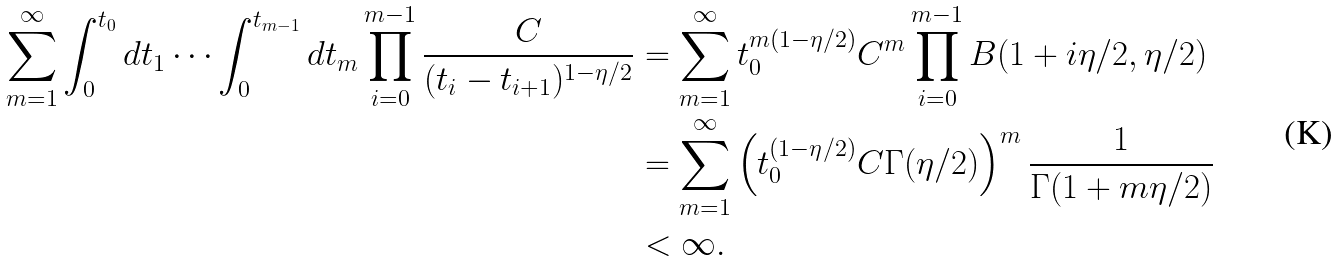Convert formula to latex. <formula><loc_0><loc_0><loc_500><loc_500>\sum _ { m = 1 } ^ { \infty } \int _ { 0 } ^ { t _ { 0 } } d t _ { 1 } \cdots \int _ { 0 } ^ { t _ { m - 1 } } d t _ { m } \prod _ { i = 0 } ^ { m - 1 } \frac { C } { ( t _ { i } - t _ { i + 1 } ) ^ { 1 - \eta / 2 } } & = \sum _ { m = 1 } ^ { \infty } t _ { 0 } ^ { m ( 1 - \eta / 2 ) } C ^ { m } \prod _ { i = 0 } ^ { m - 1 } B ( 1 + i \eta / 2 , \eta / 2 ) \\ & = \sum _ { m = 1 } ^ { \infty } \left ( t _ { 0 } ^ { ( 1 - \eta / 2 ) } C \Gamma ( \eta / 2 ) \right ) ^ { m } \frac { 1 } { \Gamma ( 1 + m \eta / 2 ) } \\ & < \infty .</formula> 